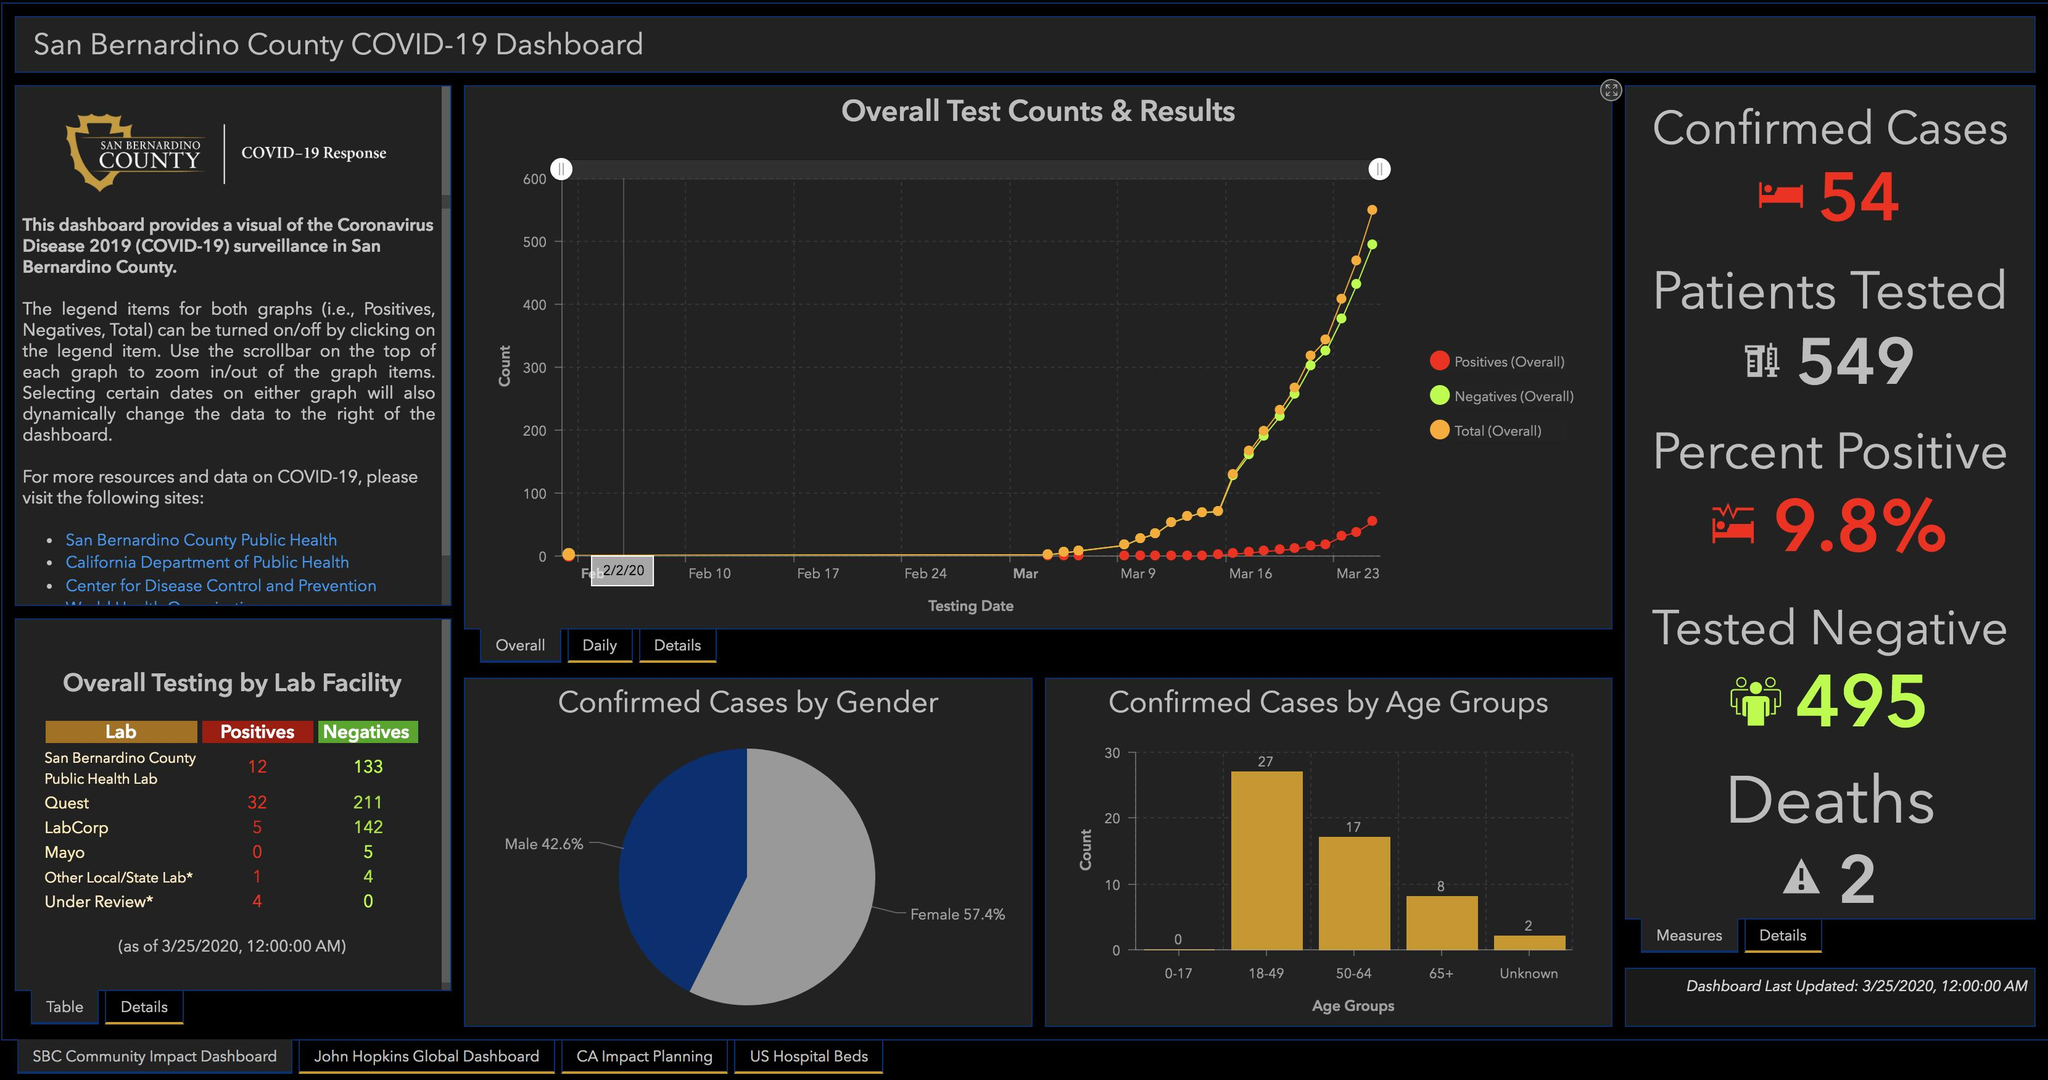Draw attention to some important aspects in this diagram. According to recent data, women are more likely to contract COVID-19 than men. The lab that reported the highest number of negative cases is... There are 25 infected people over the age of 50. Quest Diagnostics, a leading laboratory, tested the most number of samples in its lab. The total number of negative cases from all the labs is 495. 